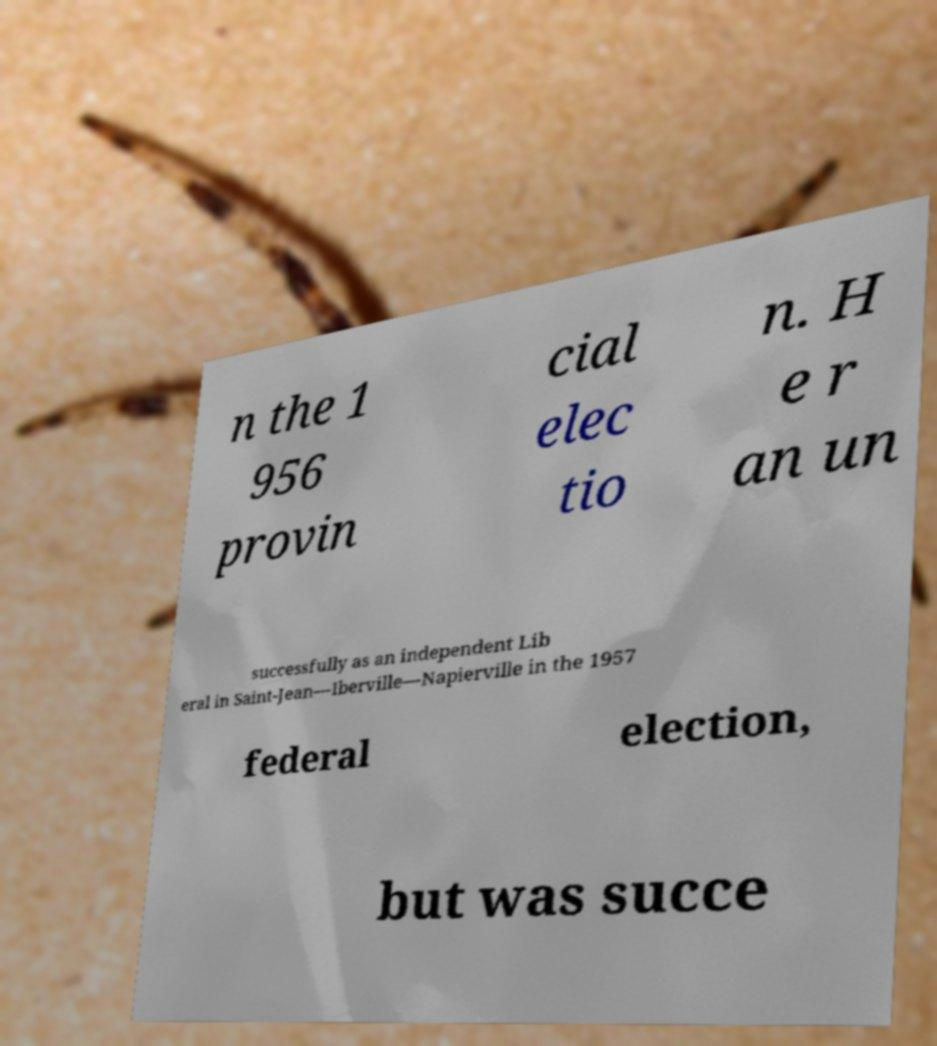Could you assist in decoding the text presented in this image and type it out clearly? n the 1 956 provin cial elec tio n. H e r an un successfully as an independent Lib eral in Saint-Jean—Iberville—Napierville in the 1957 federal election, but was succe 